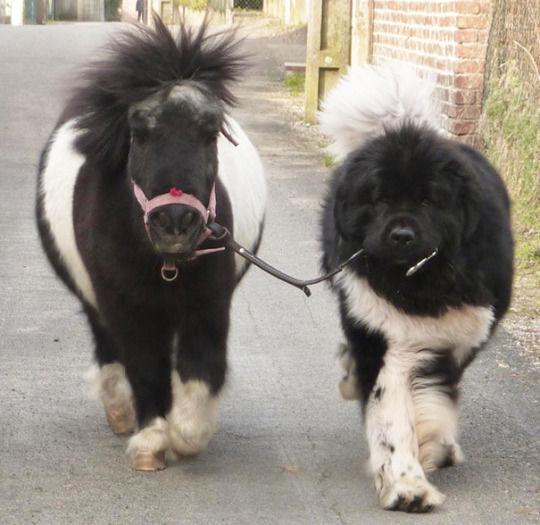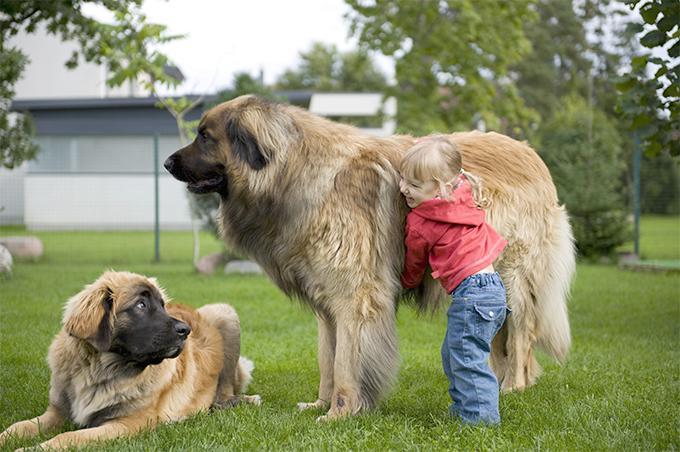The first image is the image on the left, the second image is the image on the right. For the images shown, is this caption "Dog sits with humans on a couch." true? Answer yes or no. No. 